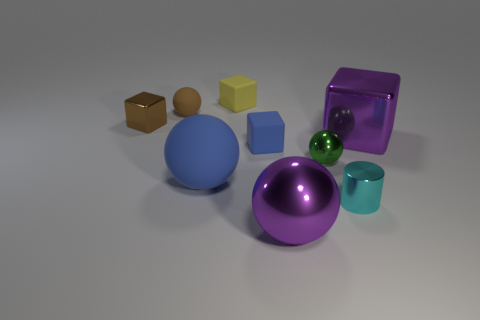What could be the sizes of these objects if I were to compare them to everyday items? If we were to compare the sizes of these objects to common household items, the large blue sphere might be similar in size to a basketball, while the small green sphere could be compared to a marble. The brown and yellow cubes could be likened to dice, and the sizeable purple cube could be as big as a small cardboard box. The cyan cylinder might share its size with a thick marker or a small cup. 